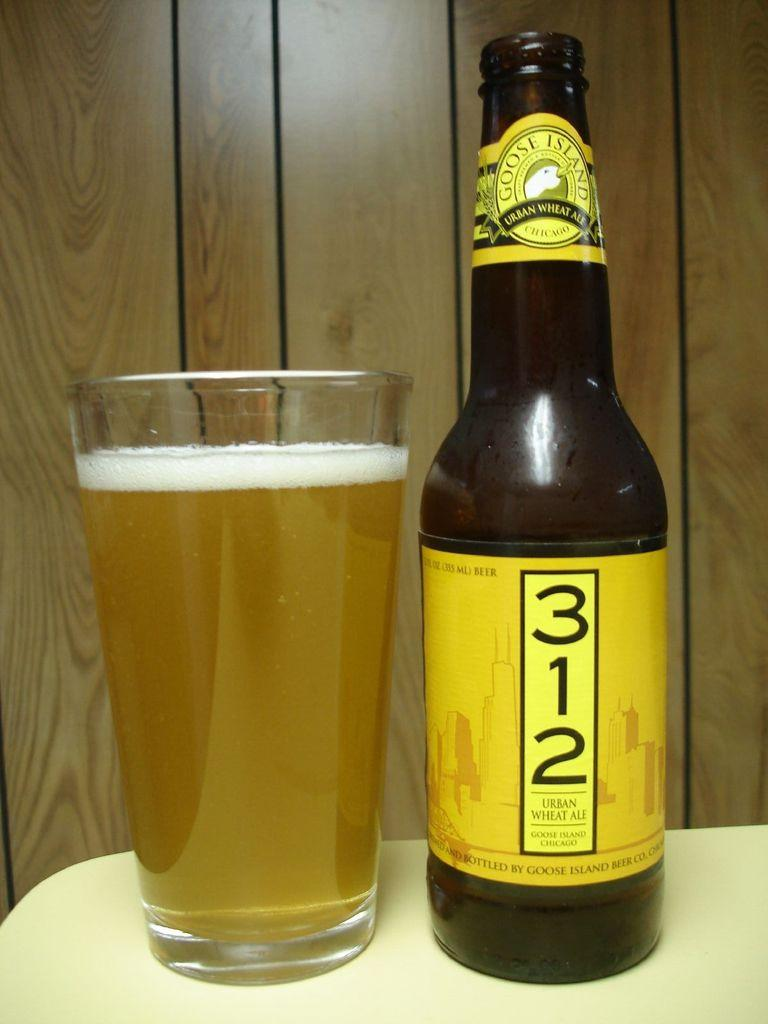<image>
Give a short and clear explanation of the subsequent image. A bottle with a yellow label that is Goose Island 312 next to a glass of the beer. 